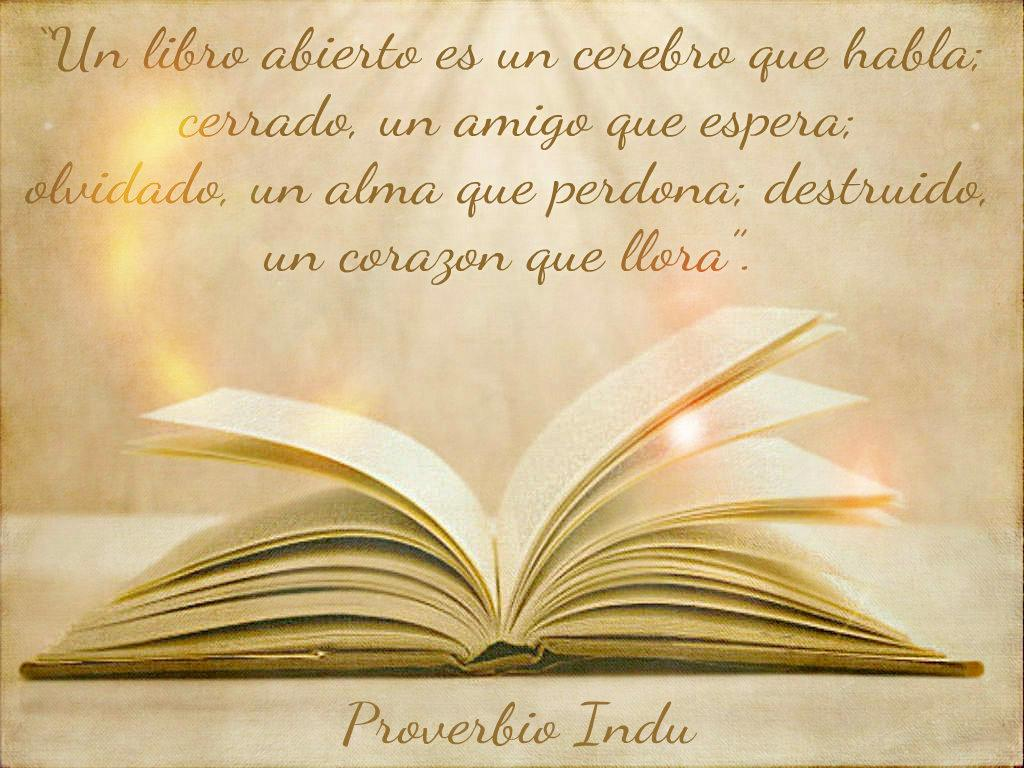<image>
Summarize the visual content of the image. An open bible displays a verse from Proverbs. 